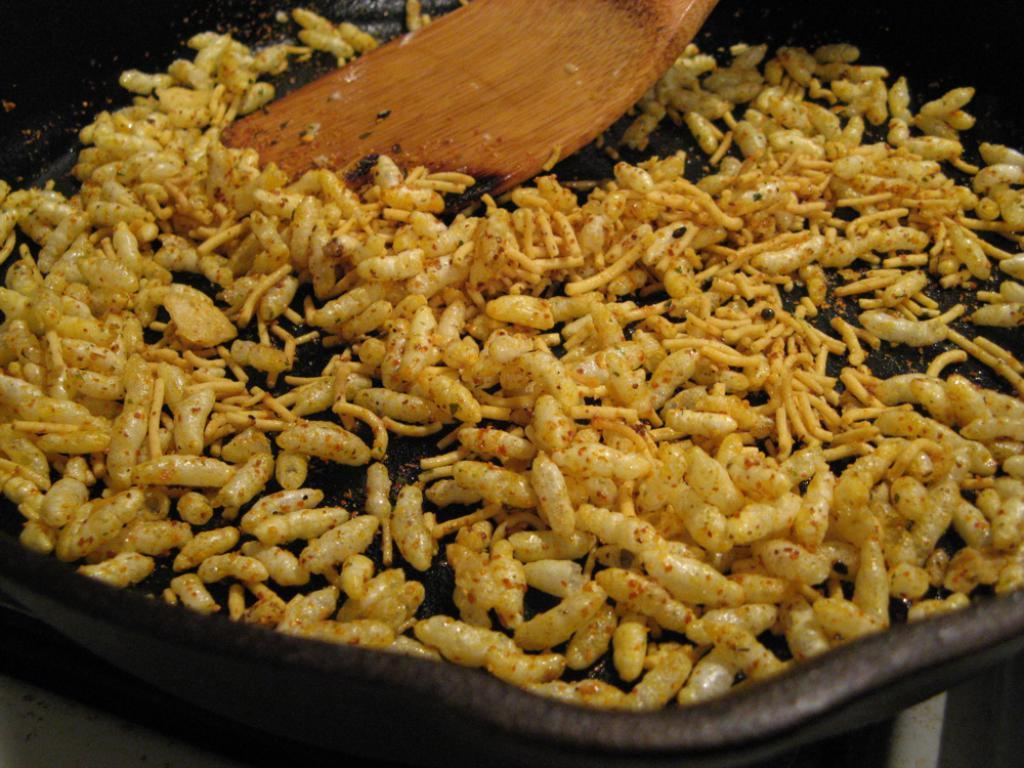What is being cooked in the pan in the image? There is a poha in a pan in the image. What utensil is visible in the image? There is a wooden spoon in the image. How many ladybugs are crawling on the wooden spoon in the image? There are no ladybugs present in the image; only the poha in the pan and the wooden spoon are visible. 